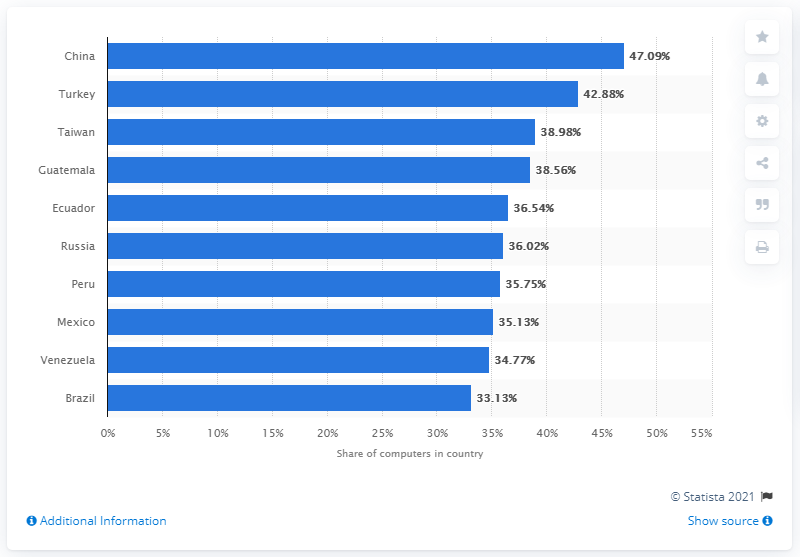Identify some key points in this picture. Turkey was ranked second with a 42.88 percent infection rate among the countries surveyed. 